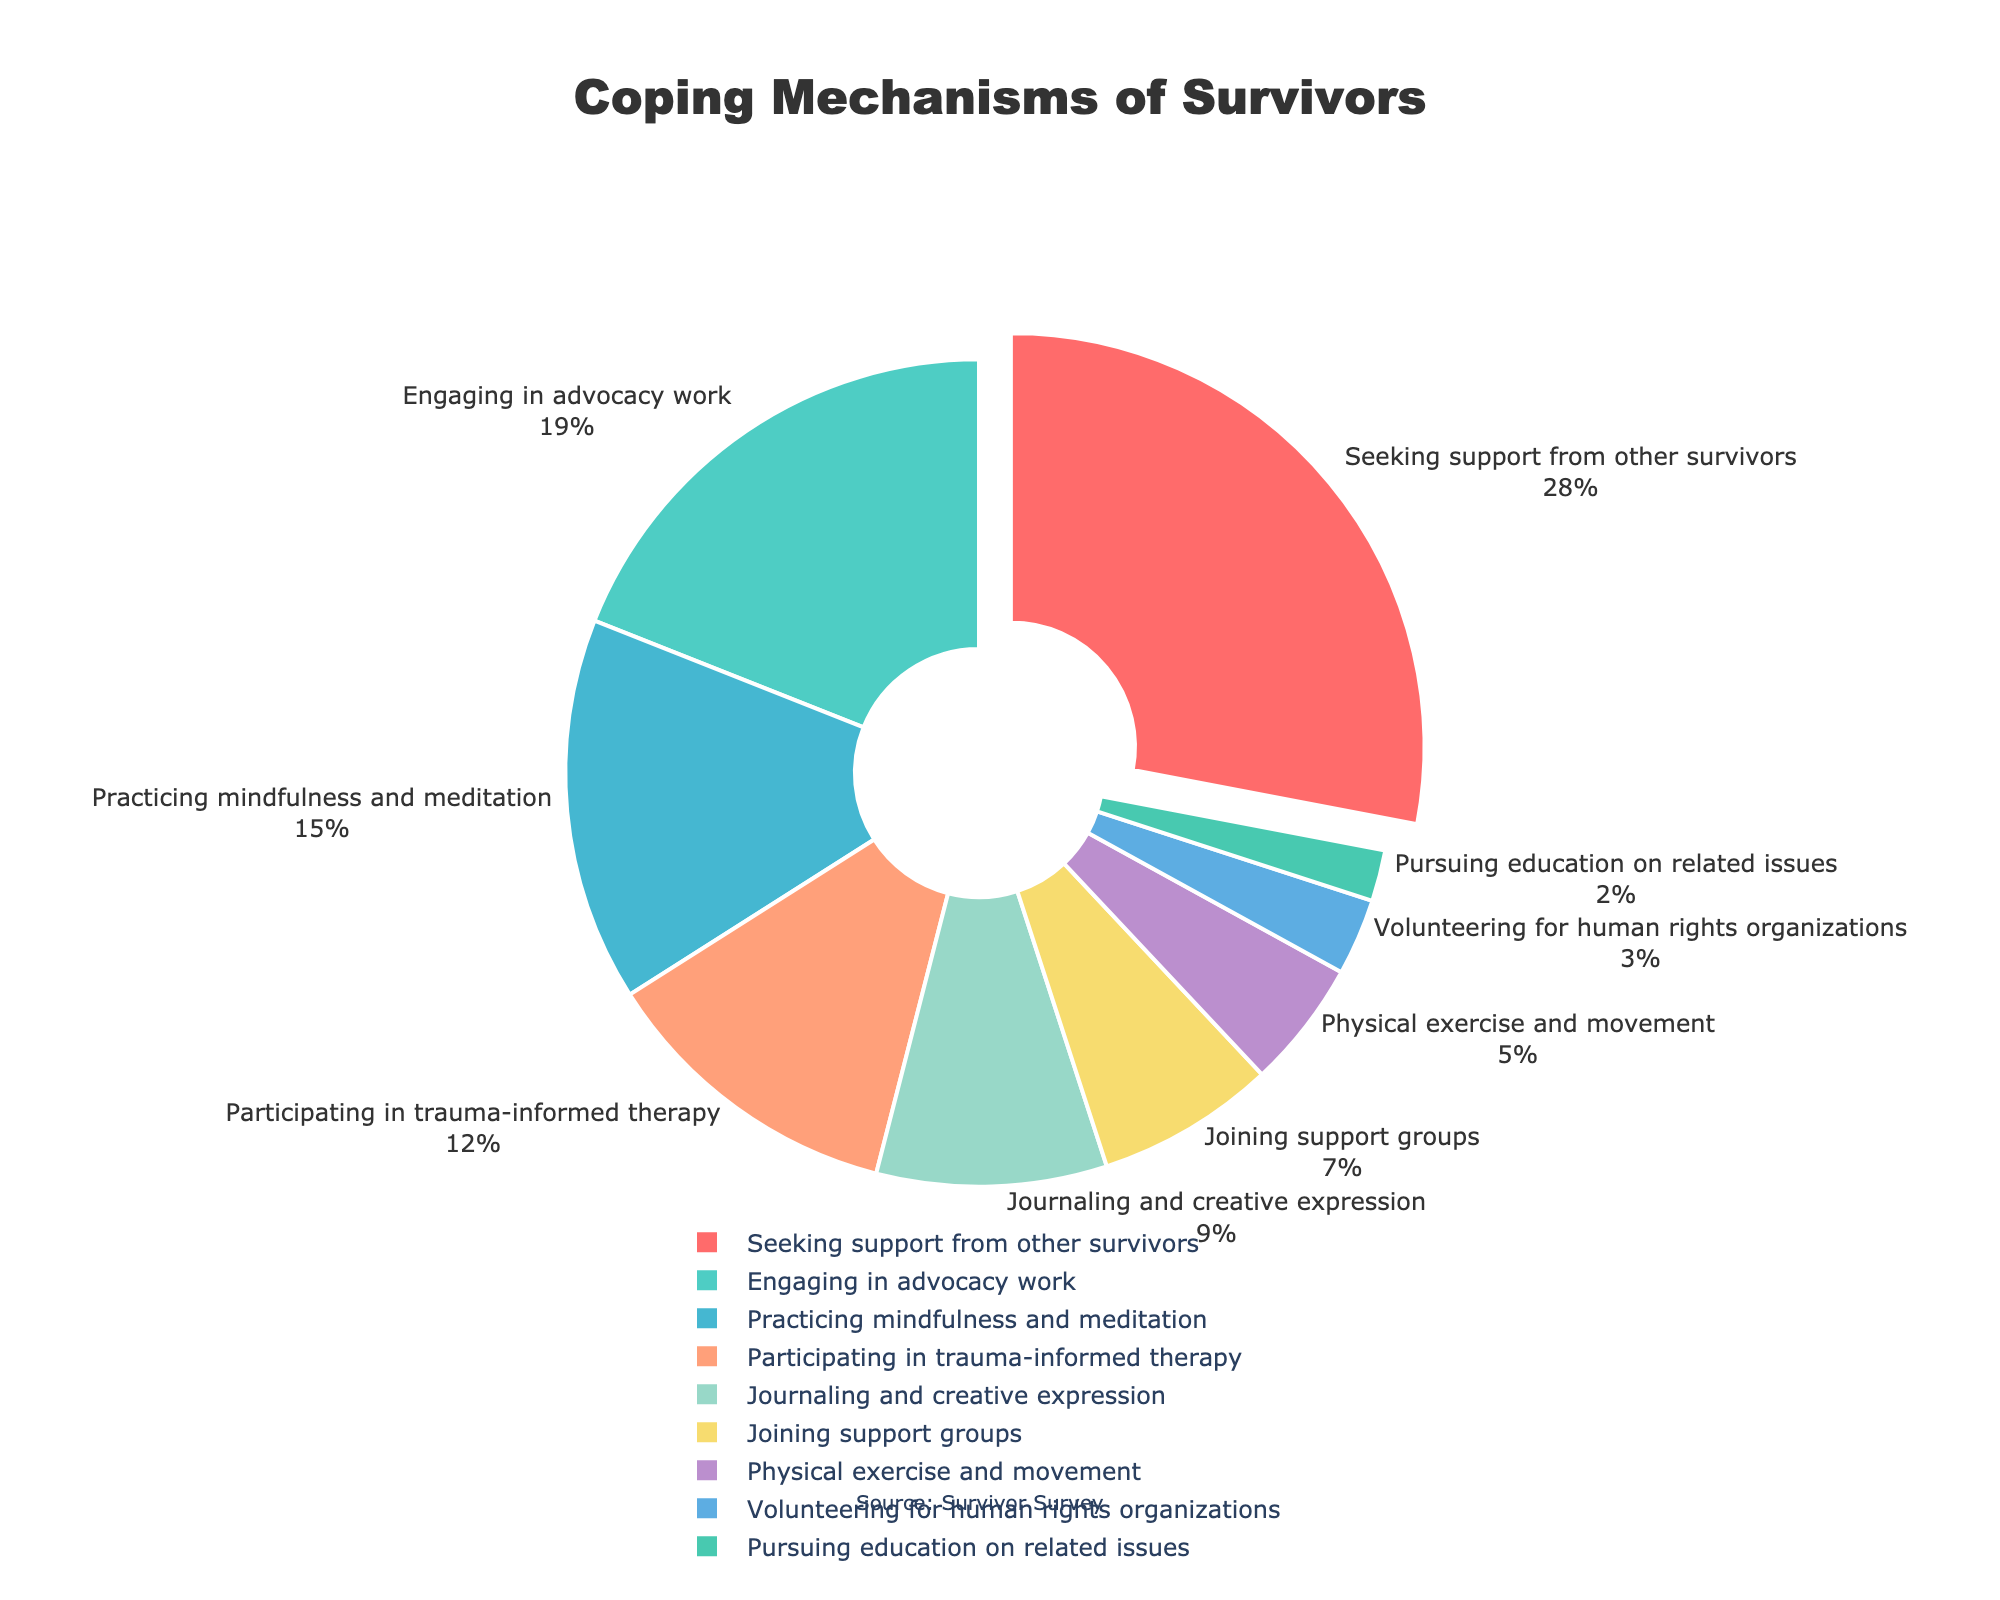what is the most common coping mechanism among survivors? The pie chart shows the percentage of survivors who engage in various coping mechanisms. The largest slice of the pie chart represents seeking support from other survivors, which takes up 28%.
Answer: seeking support from other survivors what percentage of survivors engage in both journaling and creative expression and physical exercise and movement combined? Add the percentages of the two coping mechanisms: Journaling and creative expression (9%) + Physical exercise and movement (5%) = 14%.
Answer: 14% Which coping mechanism has a higher percentage, practicing mindfulness and meditation or participating in trauma-informed therapy? Compare the percentages: Practicing mindfulness and meditation (15%) is higher than Participating in trauma-informed therapy (12%).
Answer: practicing mindfulness and meditation what is the difference in percentage between engaging in advocacy work and joining support groups? Subtract the percentage of Joining support groups from the percentage of Engaging in advocacy work: 19% - 7% = 12%.
Answer: 12% what coping mechanism is represented by the red section of the pie chart? The red section of the pie chart is pulled out slightly from the circle and represents the largest percentage, which is seeking support from other survivors.
Answer: seeking support from other survivors How many coping mechanisms have a percentage of 5% or less? The coping mechanisms with percentages of 5% or less are: Physical exercise and movement (5%), Volunteering for human rights organizations (3%), and Pursuing education on related issues (2%), totaling 3 coping mechanisms.
Answer: 3 compare the combined total of survivors engaging in advocacy work and seeking support from other survivors with the sum of the rest of the coping mechanisms First find the combined total: Engaging in advocacy work (19%) + Seeking support from other survivors (28%) = 47%. Then find the sum of the rest: 100% - 47% = 53%.
Answer: 53% which coping mechanisms occupy the smallest and largest sections of the pie chart? The smallest section represents Pursuing education on related issues (2%), and the largest section represents Seeking support from other survivors (28%).
Answer: pursuing education on related issues, seeking support from other survivors 